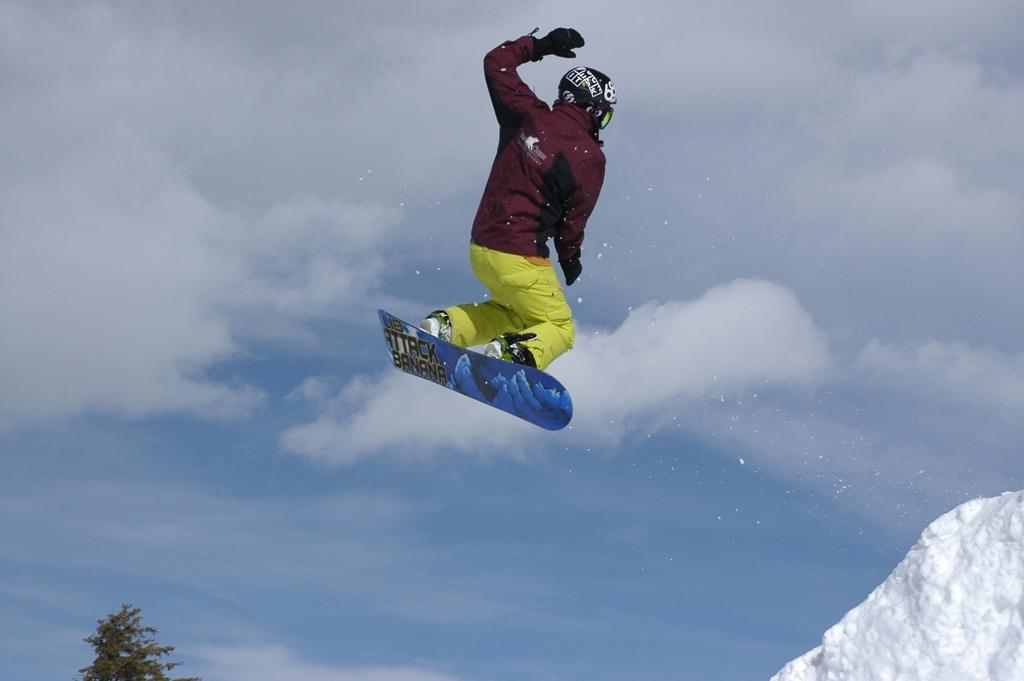What is the person in the image doing? The person is in the air with a skateboard. What can be seen in the background of the image? The sky with clouds and a tree are visible in the background. What is the ground made of in the image? Snow is present at the bottom of the image. What type of industry can be seen in the background of the image? There is no industry present in the image; it features a person in the air with a skateboard, a sky with clouds, a tree, and snow at the bottom. 